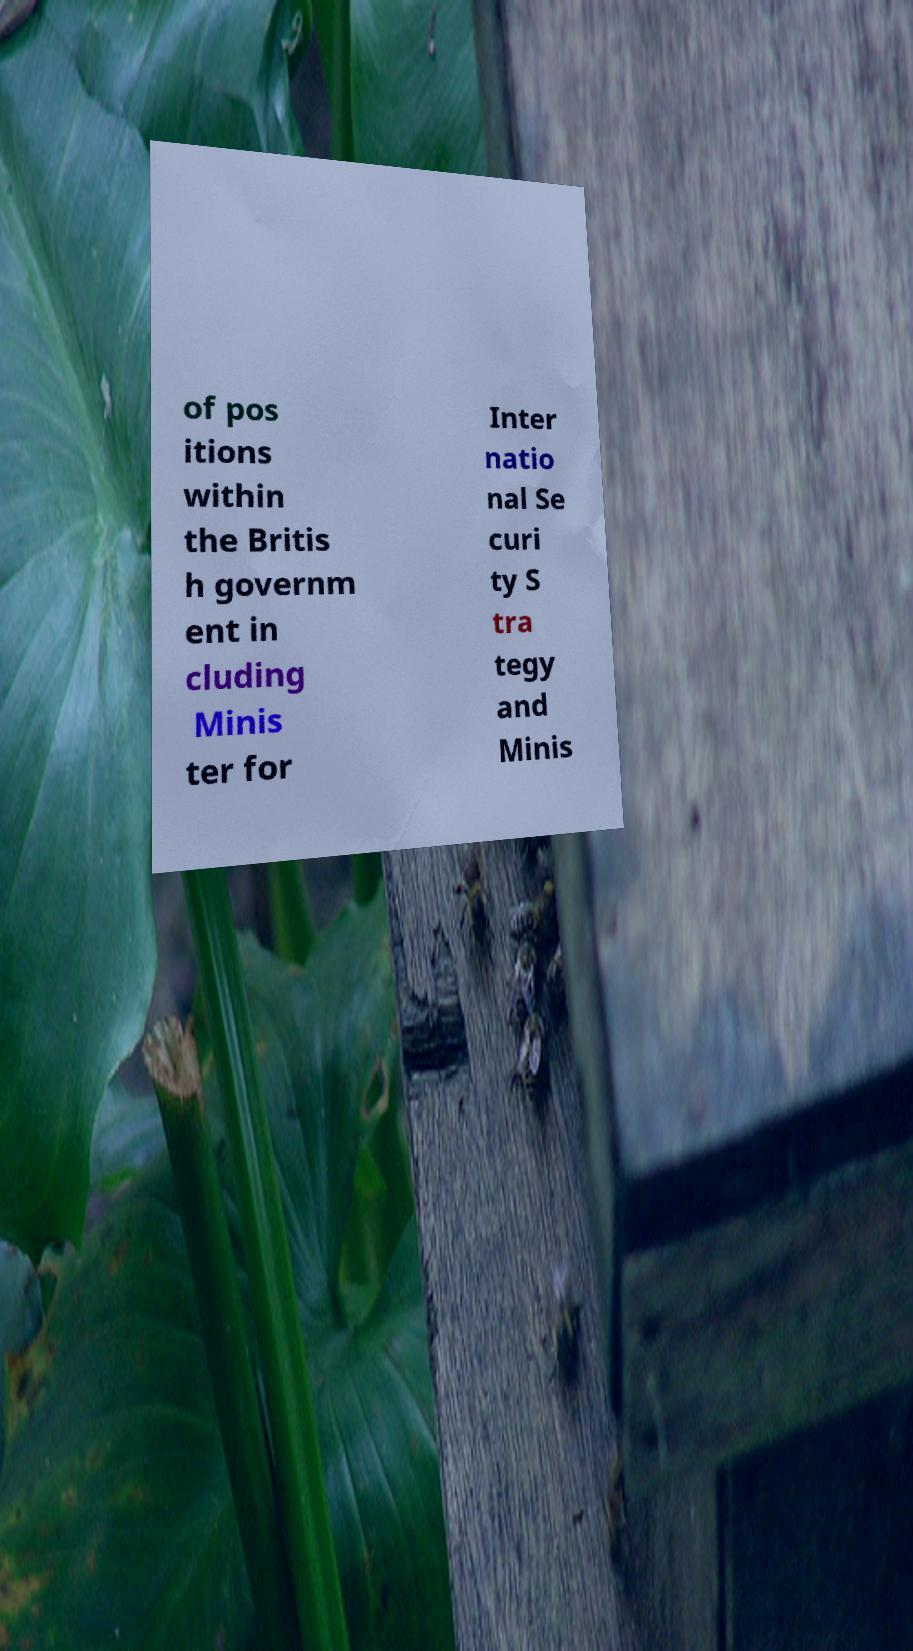For documentation purposes, I need the text within this image transcribed. Could you provide that? of pos itions within the Britis h governm ent in cluding Minis ter for Inter natio nal Se curi ty S tra tegy and Minis 